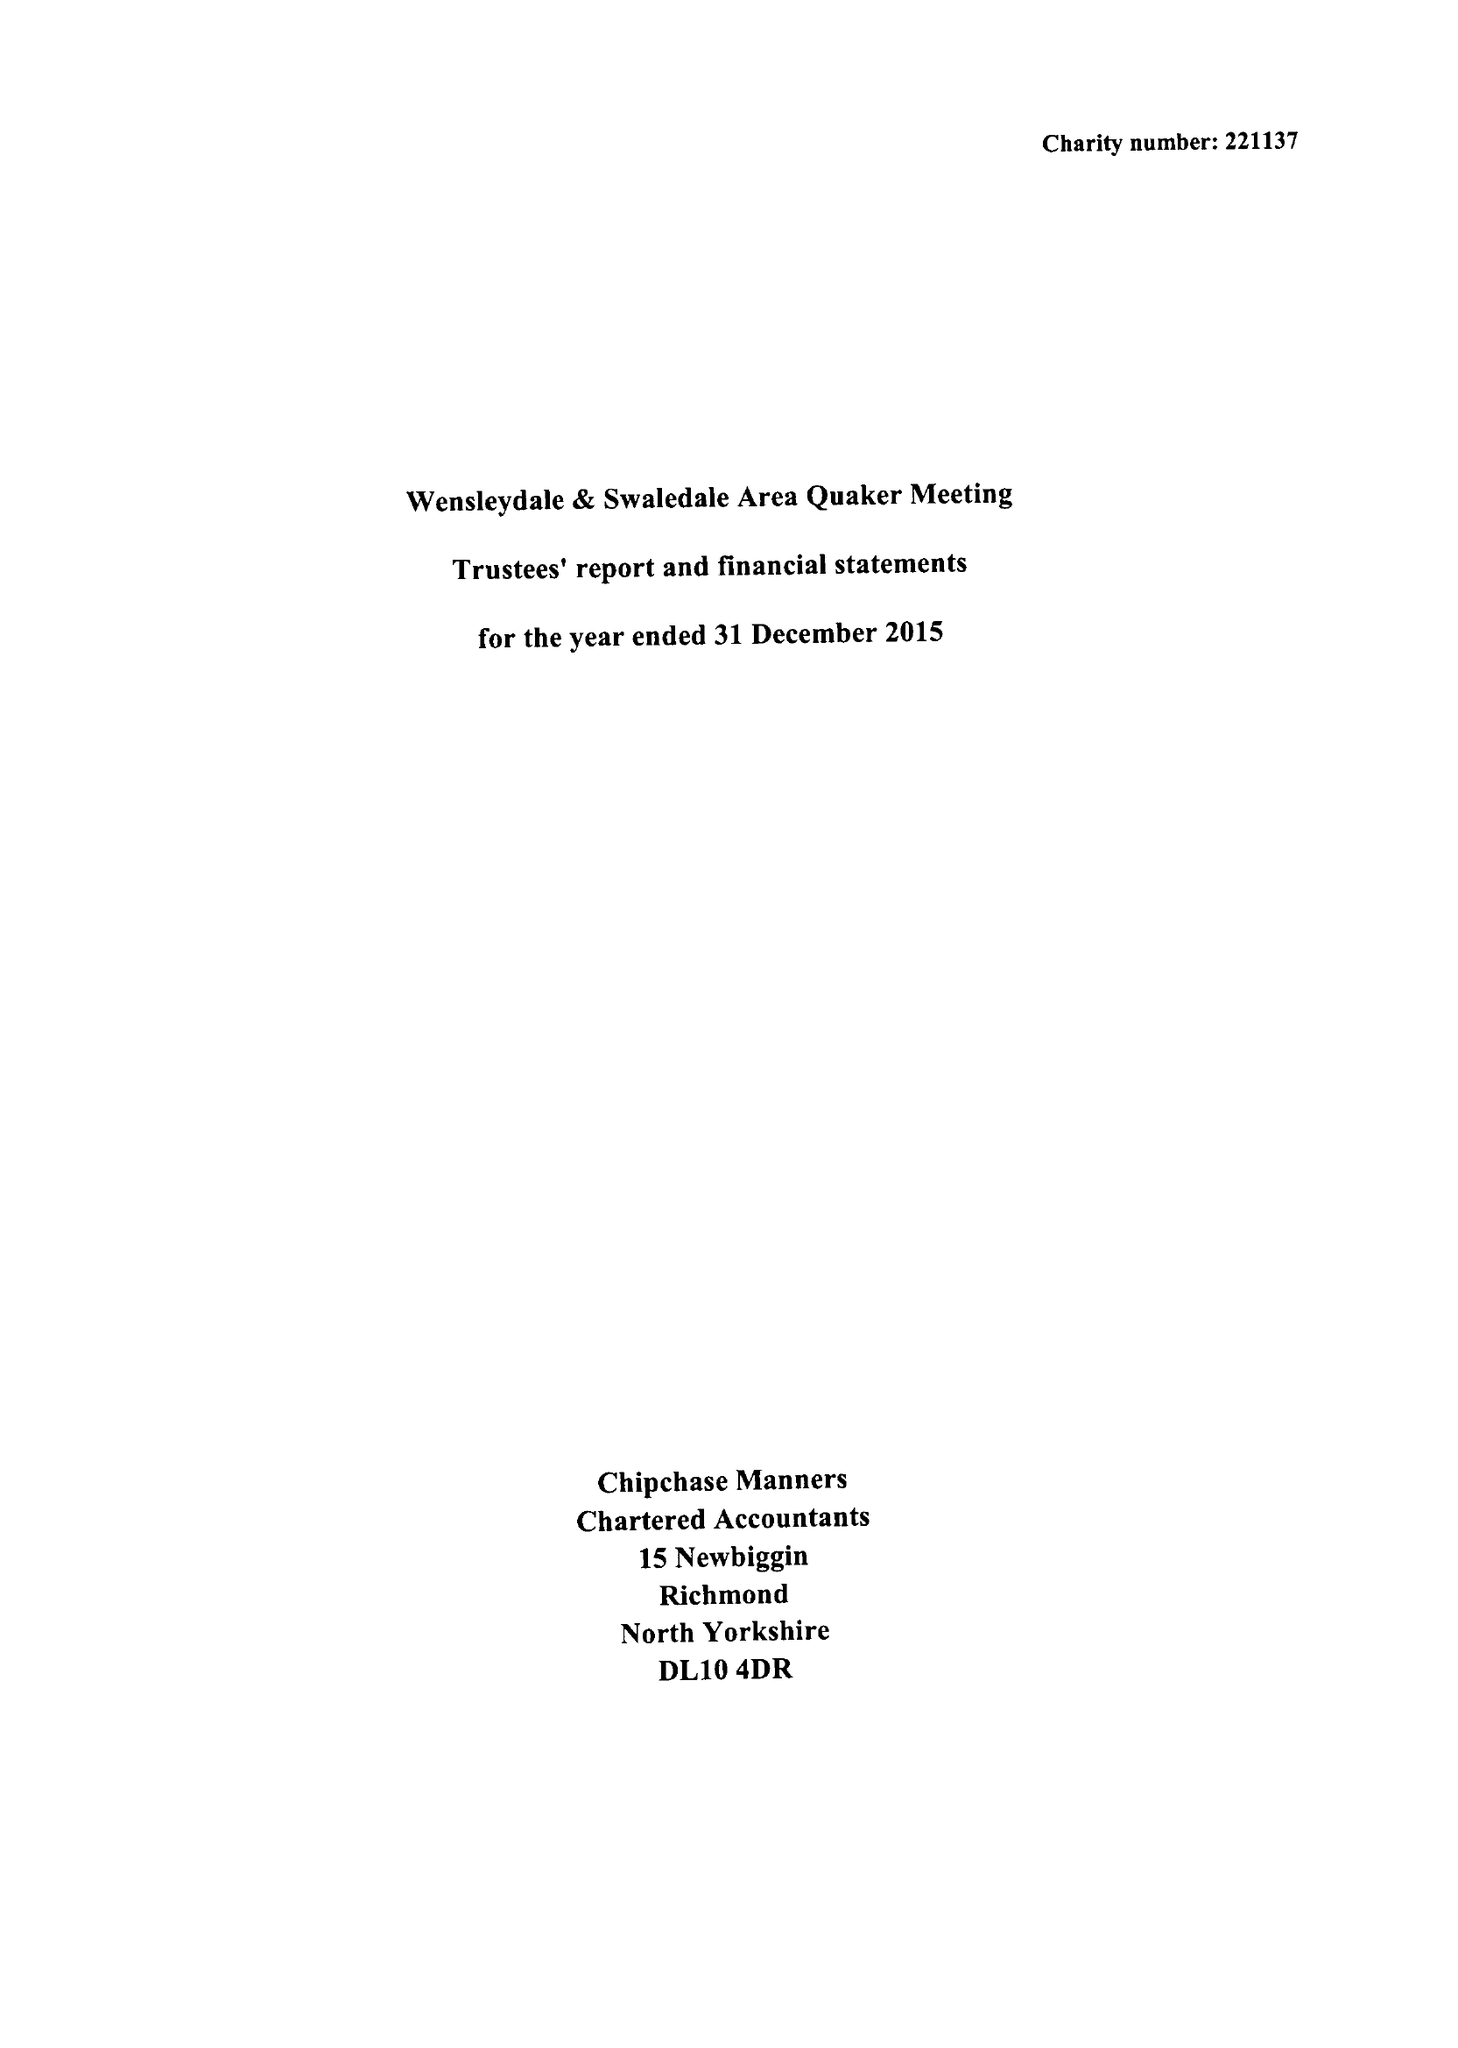What is the value for the address__postcode?
Answer the question using a single word or phrase. DL8 5AE 